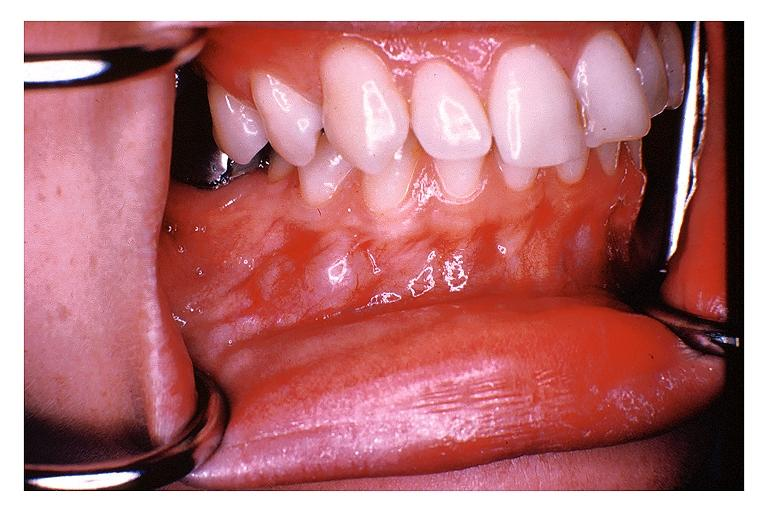s inflamed exocervix present?
Answer the question using a single word or phrase. No 